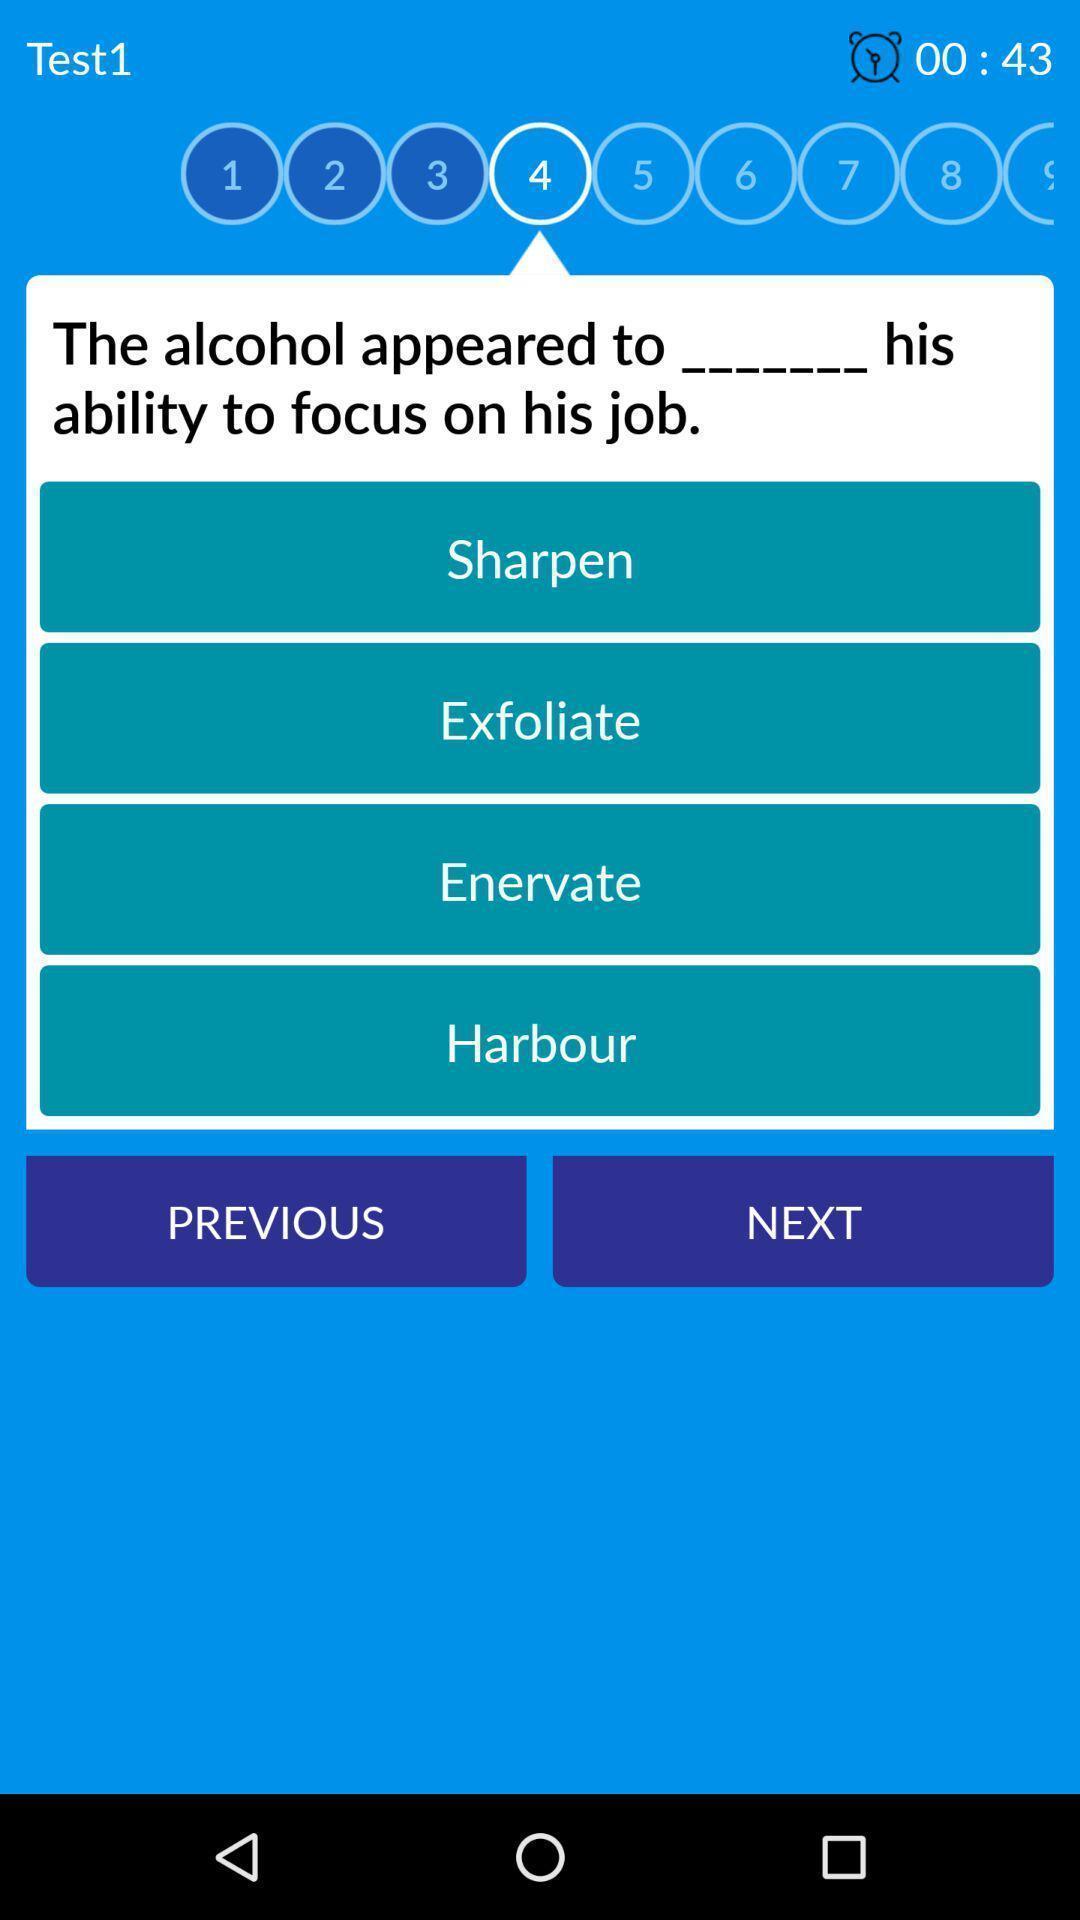Explain the elements present in this screenshot. Screen showing the page of vocabulary learning app. 